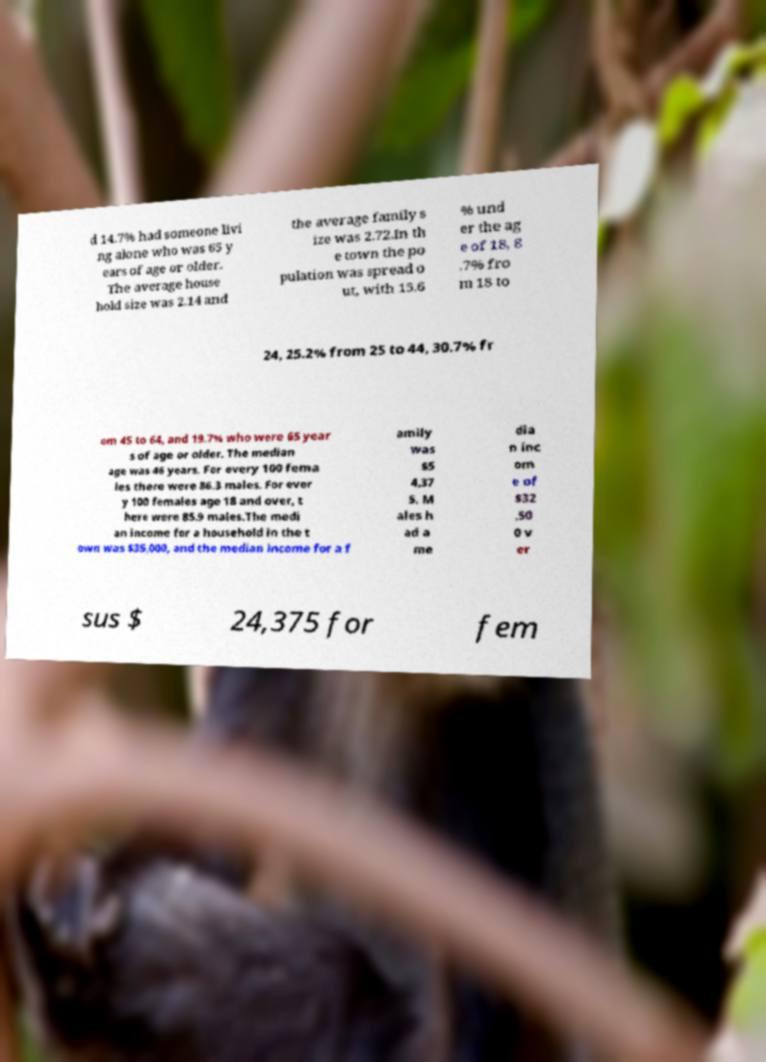Could you extract and type out the text from this image? d 14.7% had someone livi ng alone who was 65 y ears of age or older. The average house hold size was 2.14 and the average family s ize was 2.72.In th e town the po pulation was spread o ut, with 15.6 % und er the ag e of 18, 8 .7% fro m 18 to 24, 25.2% from 25 to 44, 30.7% fr om 45 to 64, and 19.7% who were 65 year s of age or older. The median age was 46 years. For every 100 fema les there were 86.3 males. For ever y 100 females age 18 and over, t here were 85.9 males.The medi an income for a household in the t own was $35,000, and the median income for a f amily was $5 4,37 5. M ales h ad a me dia n inc om e of $32 ,50 0 v er sus $ 24,375 for fem 